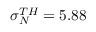Convert formula to latex. <formula><loc_0><loc_0><loc_500><loc_500>\sigma _ { N } ^ { T H } = 5 . 8 8</formula> 